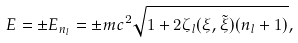<formula> <loc_0><loc_0><loc_500><loc_500>E = \pm E _ { n _ { l } } = \pm m c ^ { 2 } \sqrt { 1 + 2 \zeta _ { l } ( \xi , \tilde { \xi } ) ( n _ { l } + 1 ) } ,</formula> 